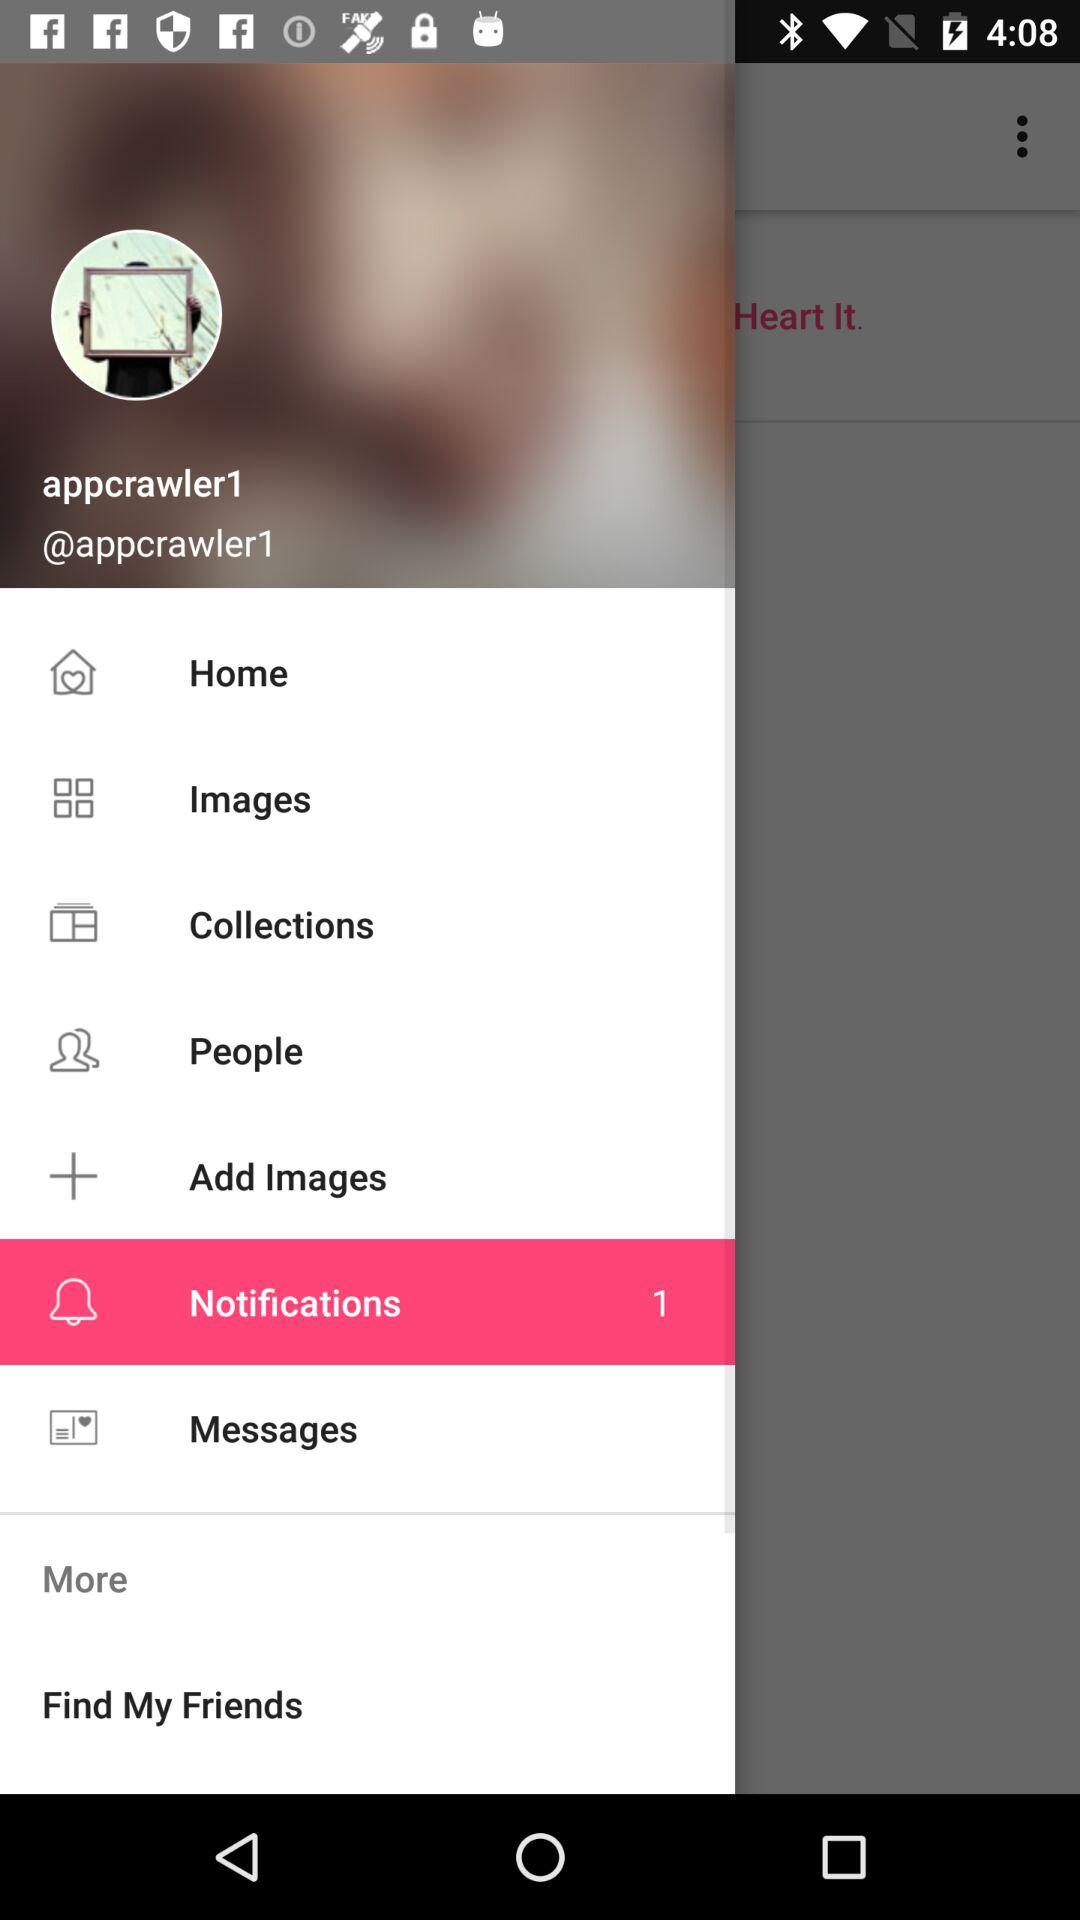What is the date?
When the provided information is insufficient, respond with <no answer>. <no answer> 